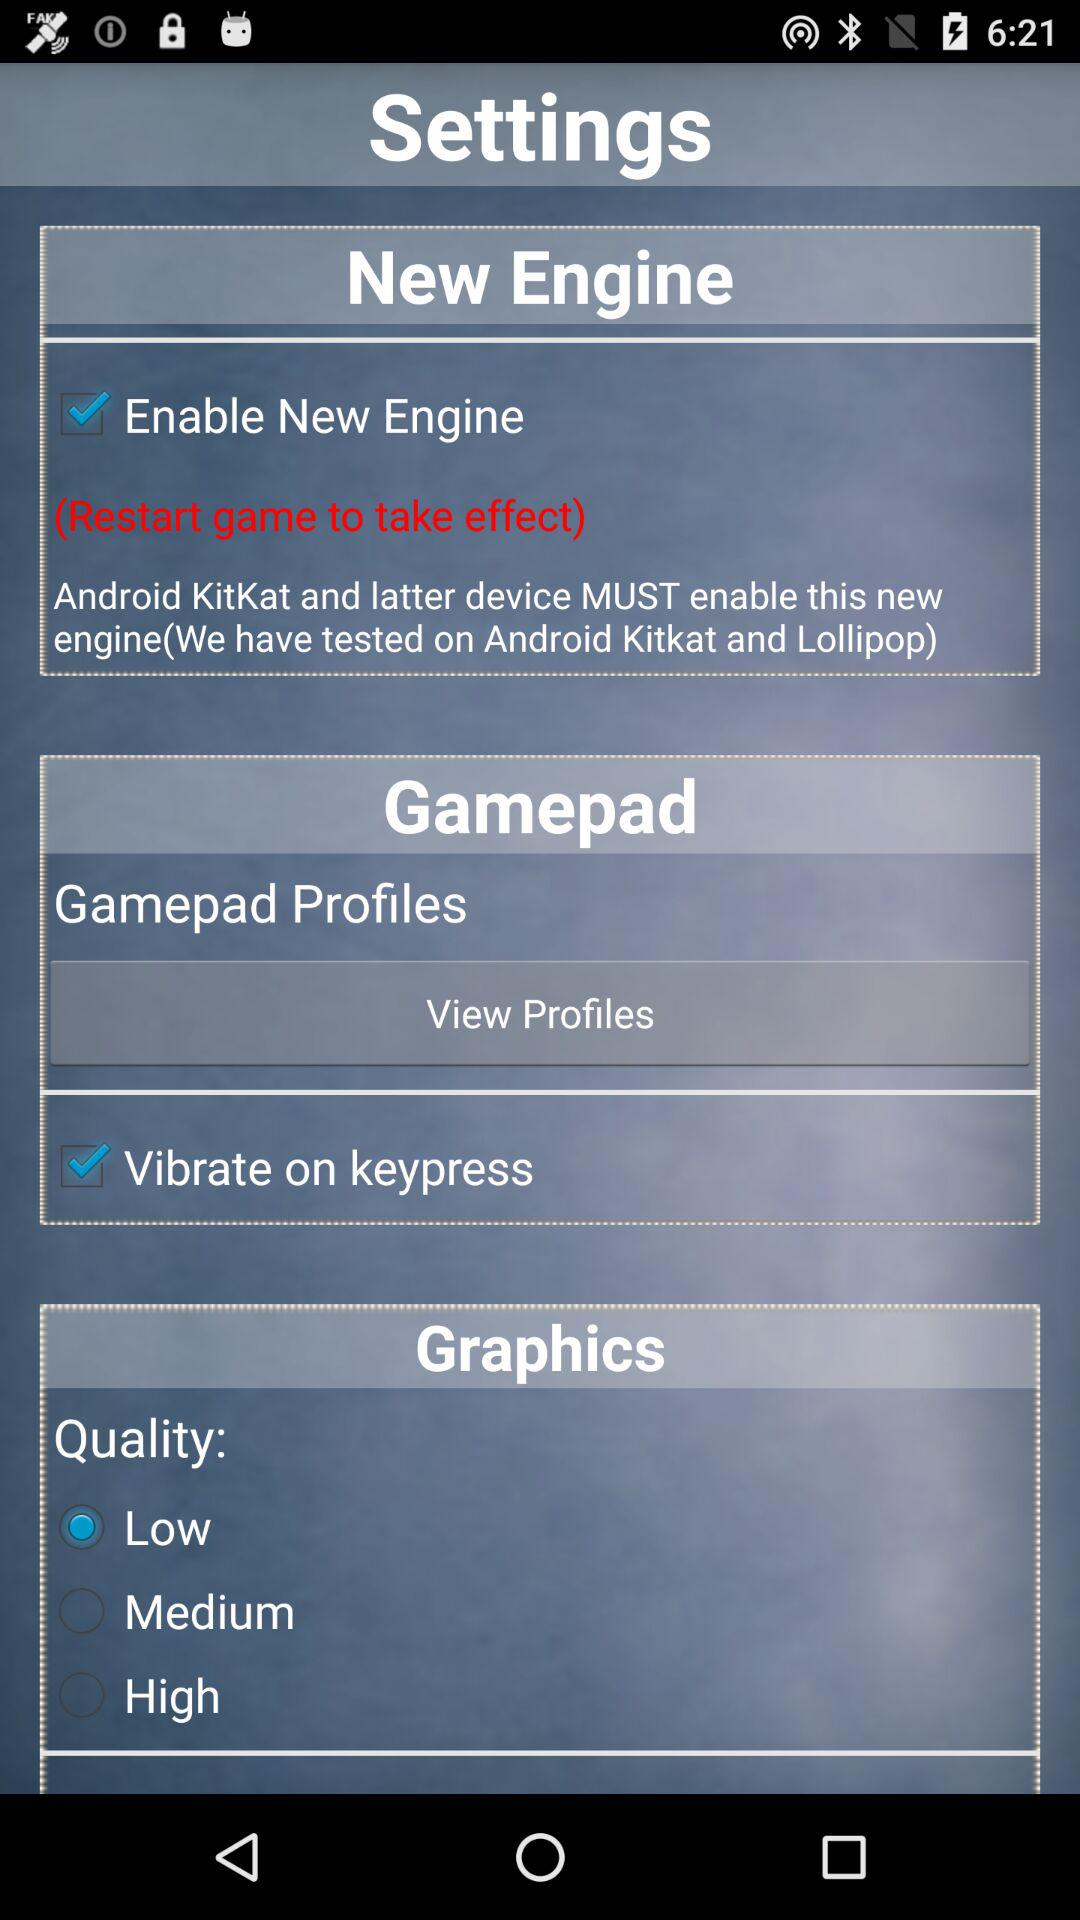What is the status of "Enable New Engine"? The status is "on". 